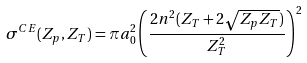<formula> <loc_0><loc_0><loc_500><loc_500>\sigma ^ { C E } ( Z _ { p } , Z _ { T } ) = { \pi } a _ { 0 } ^ { 2 } \left ( \frac { 2 n ^ { 2 } ( Z _ { T } + 2 \sqrt { Z _ { p } Z _ { T } } ) } { Z _ { T } ^ { 2 } } \right ) ^ { 2 }</formula> 